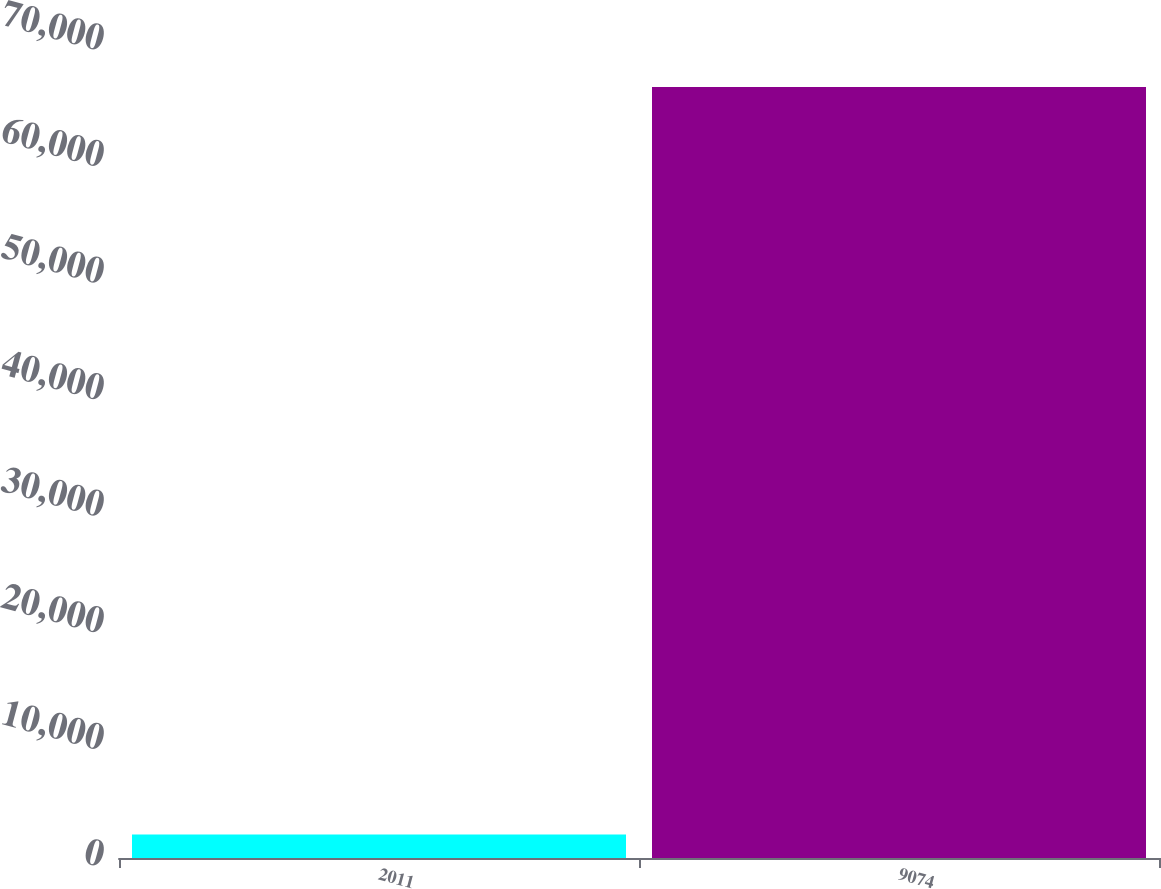Convert chart. <chart><loc_0><loc_0><loc_500><loc_500><bar_chart><fcel>2011<fcel>9074<nl><fcel>2009<fcel>66149<nl></chart> 